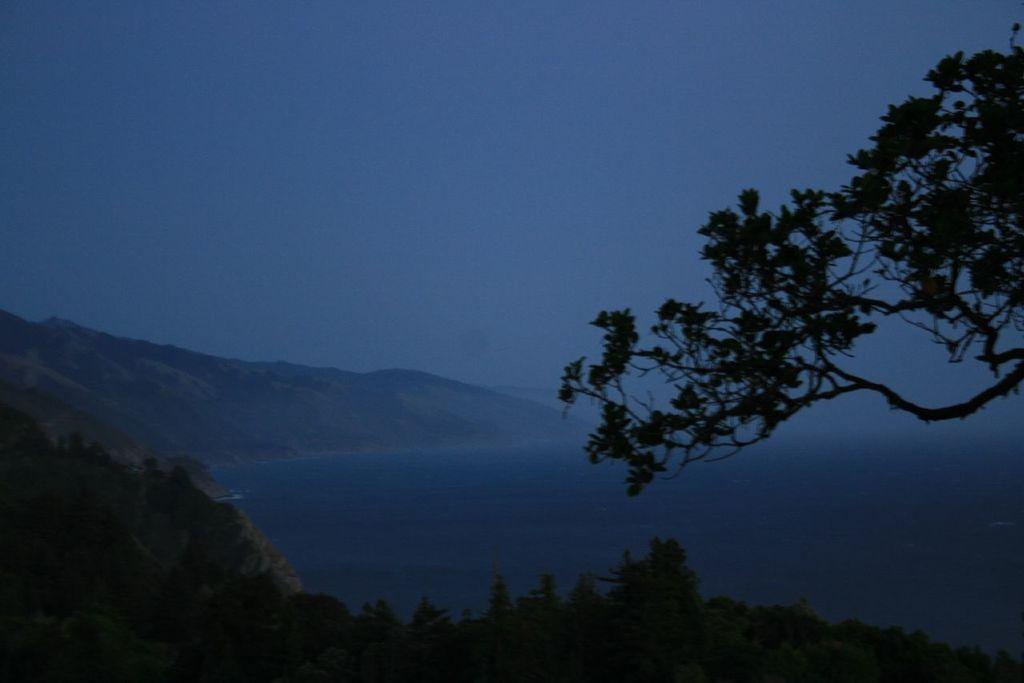What type of vegetation can be seen in the image? There are trees in the image. What is the color of the trees? The trees are green in color. What else can be seen besides the trees in the image? There is water visible in the image, as well as mountains and the sky. Can you tell me how many toads are sitting on the thread in the image? There are no toads or threads present in the image. 